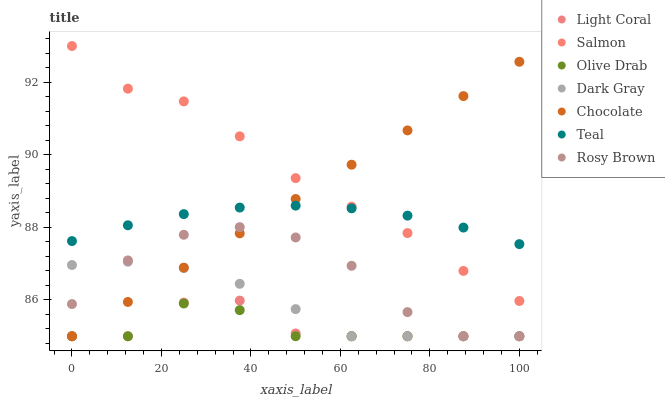Does Olive Drab have the minimum area under the curve?
Answer yes or no. Yes. Does Salmon have the maximum area under the curve?
Answer yes or no. Yes. Does Rosy Brown have the minimum area under the curve?
Answer yes or no. No. Does Rosy Brown have the maximum area under the curve?
Answer yes or no. No. Is Chocolate the smoothest?
Answer yes or no. Yes. Is Rosy Brown the roughest?
Answer yes or no. Yes. Is Salmon the smoothest?
Answer yes or no. No. Is Salmon the roughest?
Answer yes or no. No. Does Dark Gray have the lowest value?
Answer yes or no. Yes. Does Salmon have the lowest value?
Answer yes or no. No. Does Salmon have the highest value?
Answer yes or no. Yes. Does Rosy Brown have the highest value?
Answer yes or no. No. Is Olive Drab less than Teal?
Answer yes or no. Yes. Is Teal greater than Olive Drab?
Answer yes or no. Yes. Does Dark Gray intersect Chocolate?
Answer yes or no. Yes. Is Dark Gray less than Chocolate?
Answer yes or no. No. Is Dark Gray greater than Chocolate?
Answer yes or no. No. Does Olive Drab intersect Teal?
Answer yes or no. No. 